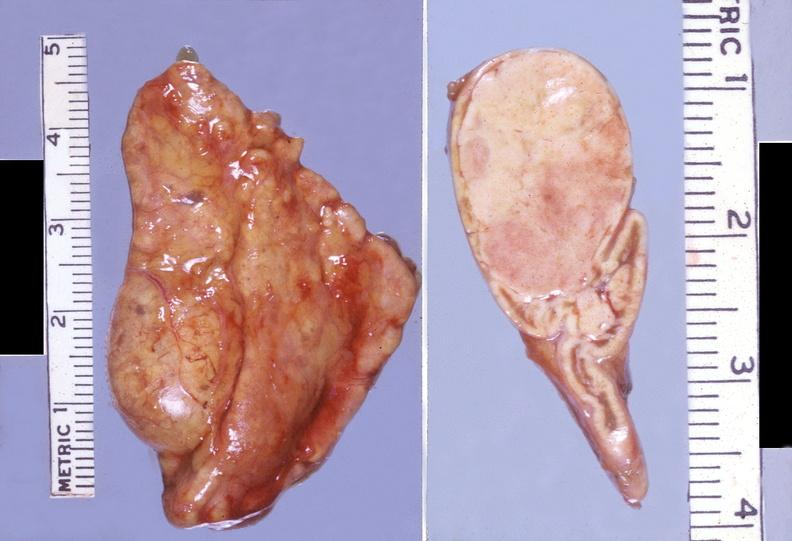what does this image show?
Answer the question using a single word or phrase. Adrenal 